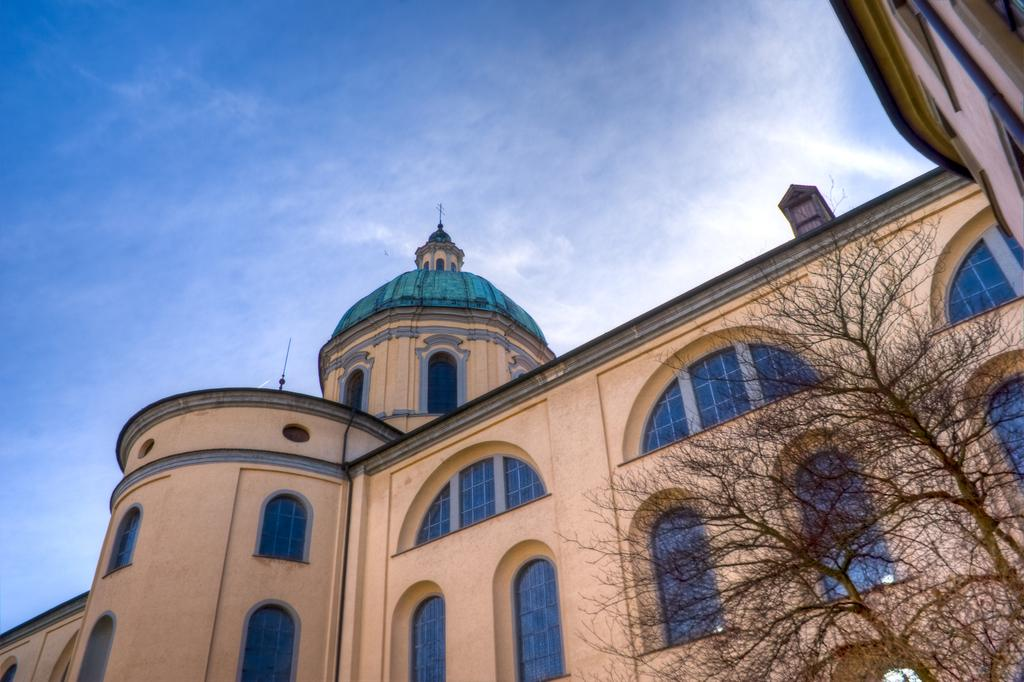What is the main subject in the center of the image? There is a building in the center of the image. What type of vegetation can be seen on the right side of the image? There are trees on the right side of the image. What is visible in the background of the image? The sky is visible in the background of the image. How many teeth can be seen on the building in the image? There are no teeth present on the building in the image. What type of berry is growing on the trees in the image? There are no berries visible on the trees in the image. 